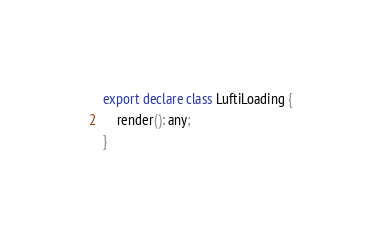Convert code to text. <code><loc_0><loc_0><loc_500><loc_500><_TypeScript_>export declare class LuftiLoading {
    render(): any;
}
</code> 